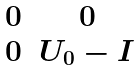<formula> <loc_0><loc_0><loc_500><loc_500>\begin{matrix} 0 & 0 \\ 0 & U _ { 0 } - I \end{matrix}</formula> 